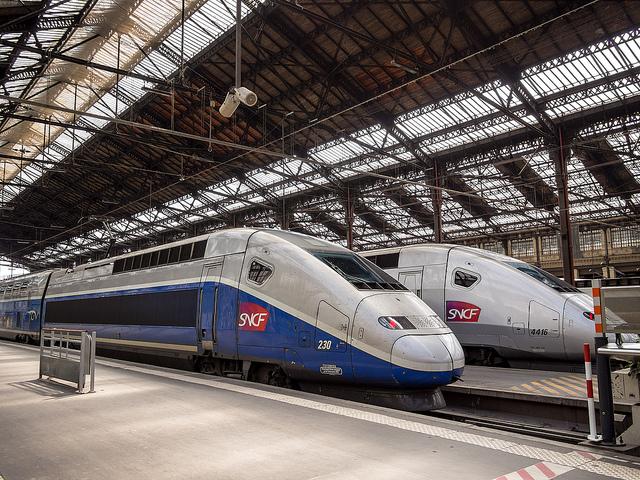Can these vehicles only follow a set path?
Keep it brief. Yes. What types of vehicles are in this picture?
Write a very short answer. Trains. Can the sky be seen through the ceiling?
Keep it brief. Yes. 